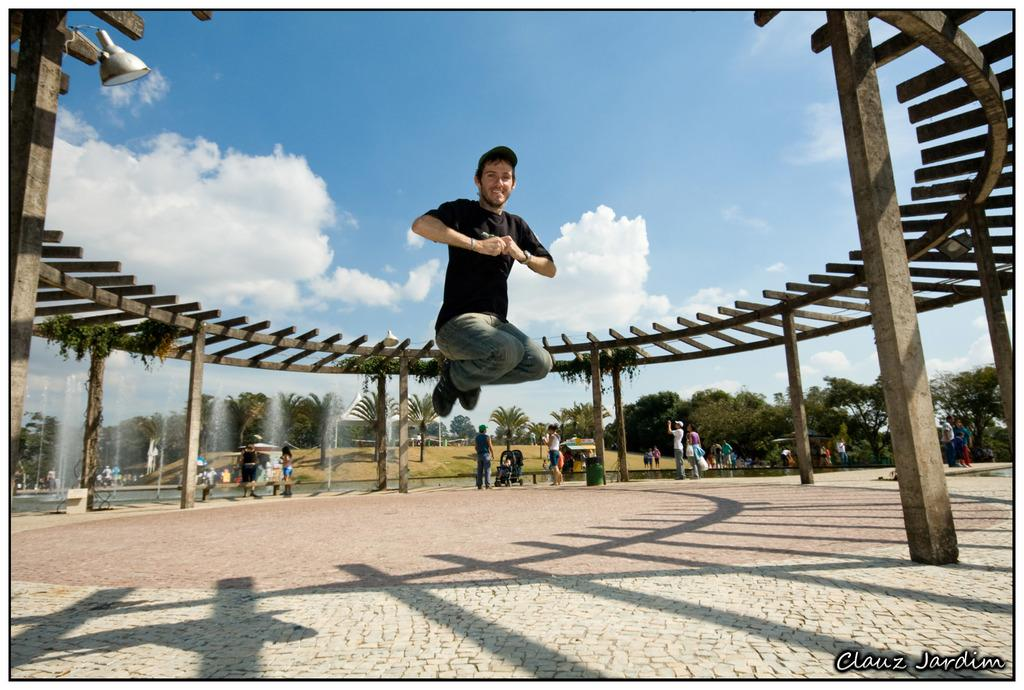Who or what is present in the image? There are people in the image. What structures can be seen in the image? There are fountains in the image. What type of vegetation is visible in the image? There are trees in the image. What is visible in the background of the image? The sky is visible in the image, and clouds are present in the sky. Can you see a receipt for the loaf of bread in the image? There is no receipt or loaf of bread present in the image. 